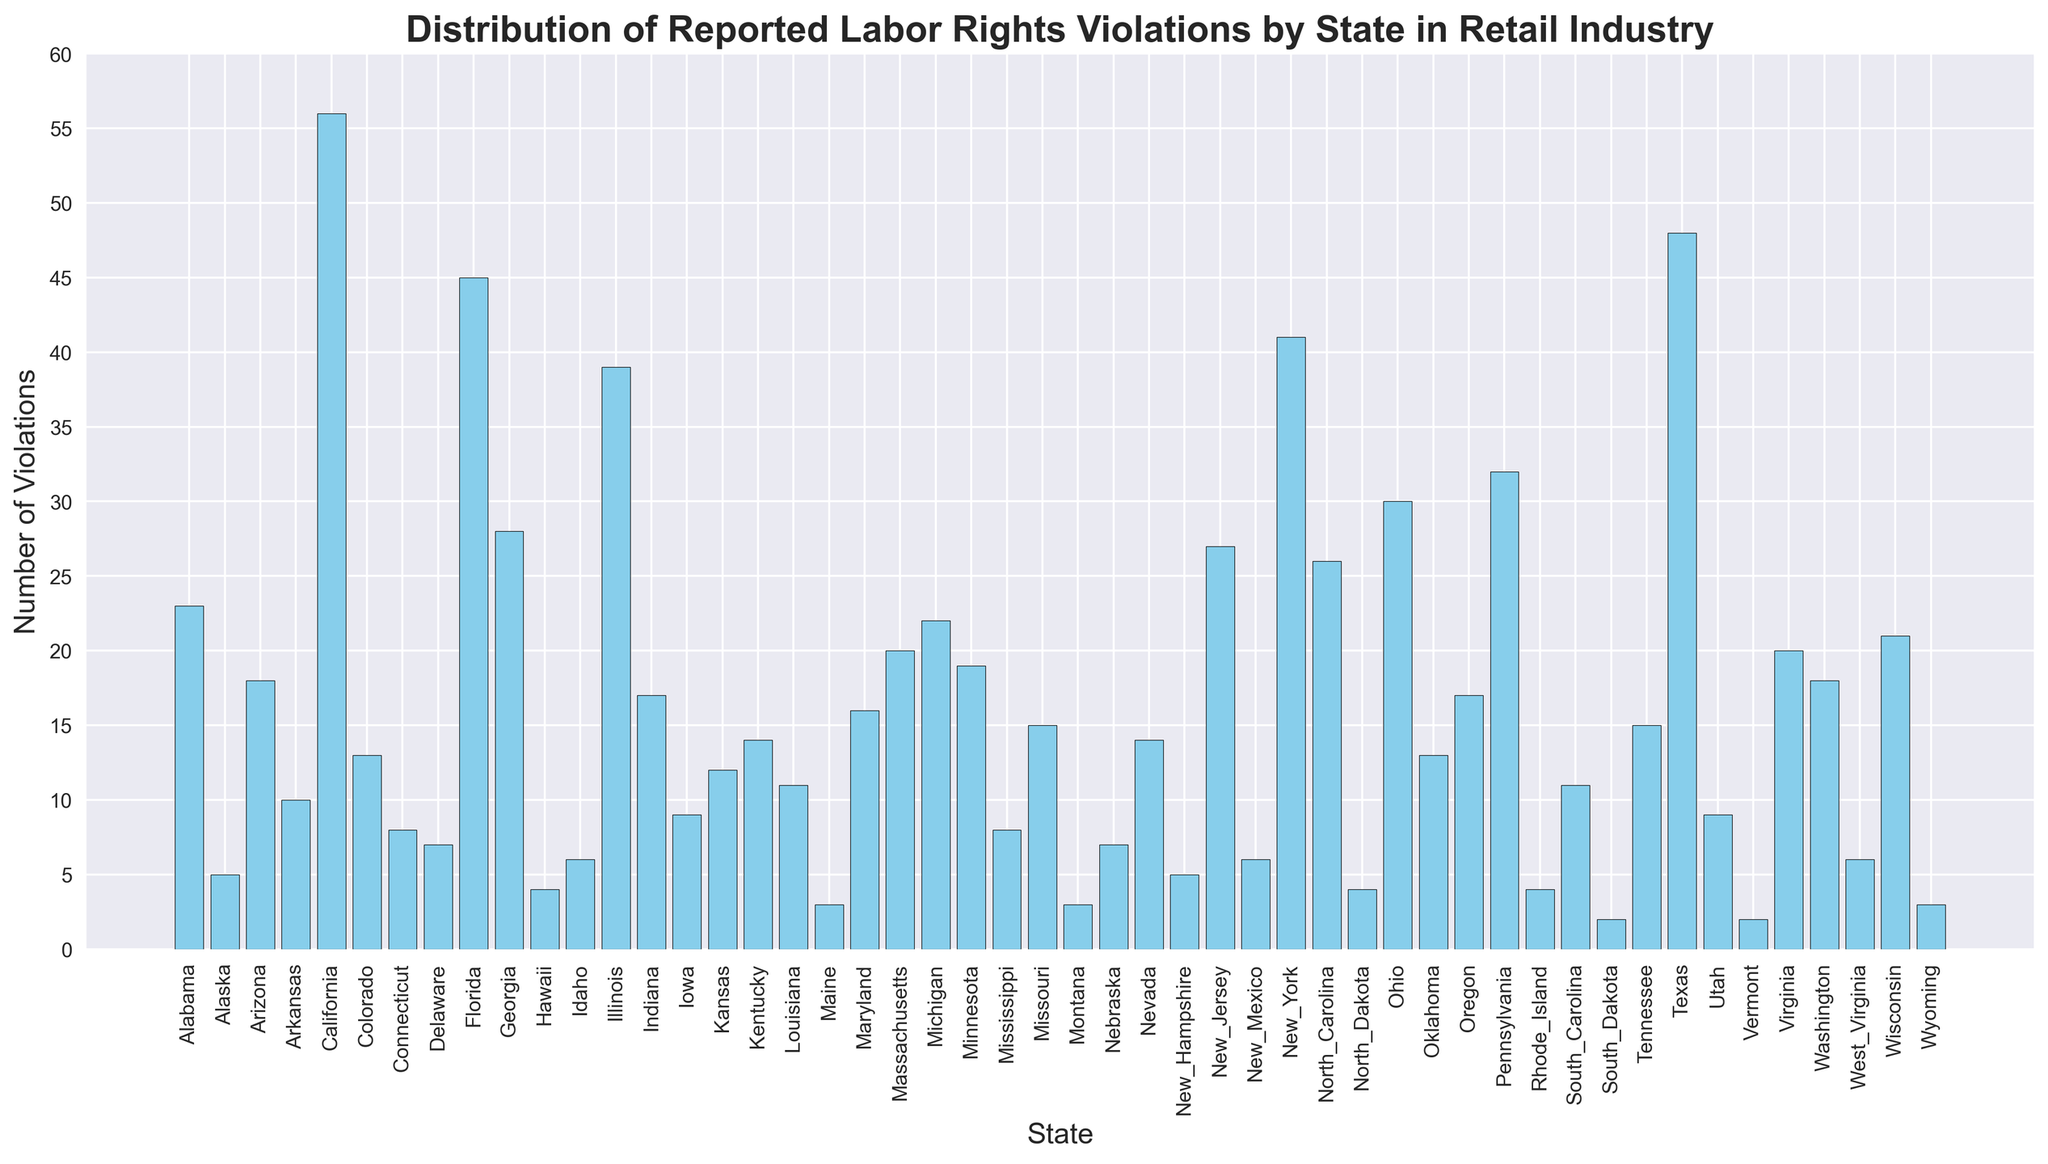Which state has the highest number of labor rights violations? Identify the tallest bar in the histogram, which represents the state with the highest number of labor rights violations. The bar for California is the tallest.
Answer: California How many states have reported over 30 labor rights violations? Count the bars that exceed the height corresponding to 30 violations. There are six states: California, Florida, Illinois, New York, Ohio, and Texas.
Answer: 6 What is the combined number of labor rights violations for New York and Pennsylvania? Locate the bars for New York and Pennsylvania and sum their heights. New York has 41 violations, and Pennsylvania has 32 violations. Their combined total is 41 + 32 = 73.
Answer: 73 Which states have fewer labor rights violations, Alabama or Colorado? Compare the heights of the bars for Alabama and Colorado. Alabama has 23 violations, and Colorado has 13.
Answer: Colorado What is the average number of labor rights violations across all states? Sum all the reported violations and divide by the number of states (51). The sum of violations is 742, and the average is 742/51 ≈ 14.55.
Answer: 14.55 Which state is represented by the third tallest bar in the histogram? Identify the third tallest bar by comparing the heights. Texas is the tallest, followed by California and then Florida.
Answer: Florida How much greater is the number of violations in Texas compared to Louisiana? Find the difference between the heights of the bars for Texas and Louisiana. Texas has 48 violations, and Louisiana has 11. The difference is 48 - 11 = 37.
Answer: 37 What is the median number of reported labor rights violations? Arrange the number of violations in ascending order and find the middle value. The middle (26th) value in the ordered list is 12.
Answer: 12 Are there more states with fewer than 10 violations or with 20 or more violations? Count the number of states with fewer than 10 violations and those with 20 or more. There are 15 states with fewer than 10 and 19 states with 20 or more violations.
Answer: More states with 20 or more violations 